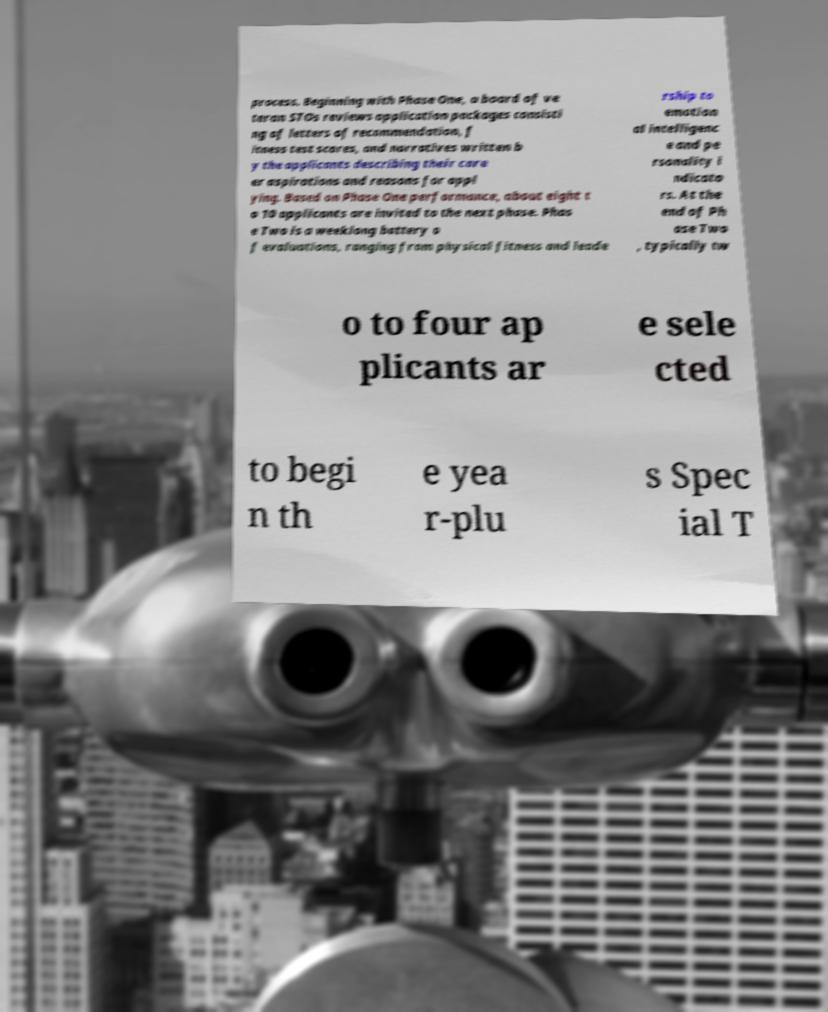Can you read and provide the text displayed in the image?This photo seems to have some interesting text. Can you extract and type it out for me? process. Beginning with Phase One, a board of ve teran STOs reviews application packages consisti ng of letters of recommendation, f itness test scores, and narratives written b y the applicants describing their care er aspirations and reasons for appl ying. Based on Phase One performance, about eight t o 10 applicants are invited to the next phase. Phas e Two is a weeklong battery o f evaluations, ranging from physical fitness and leade rship to emotion al intelligenc e and pe rsonality i ndicato rs. At the end of Ph ase Two , typically tw o to four ap plicants ar e sele cted to begi n th e yea r-plu s Spec ial T 